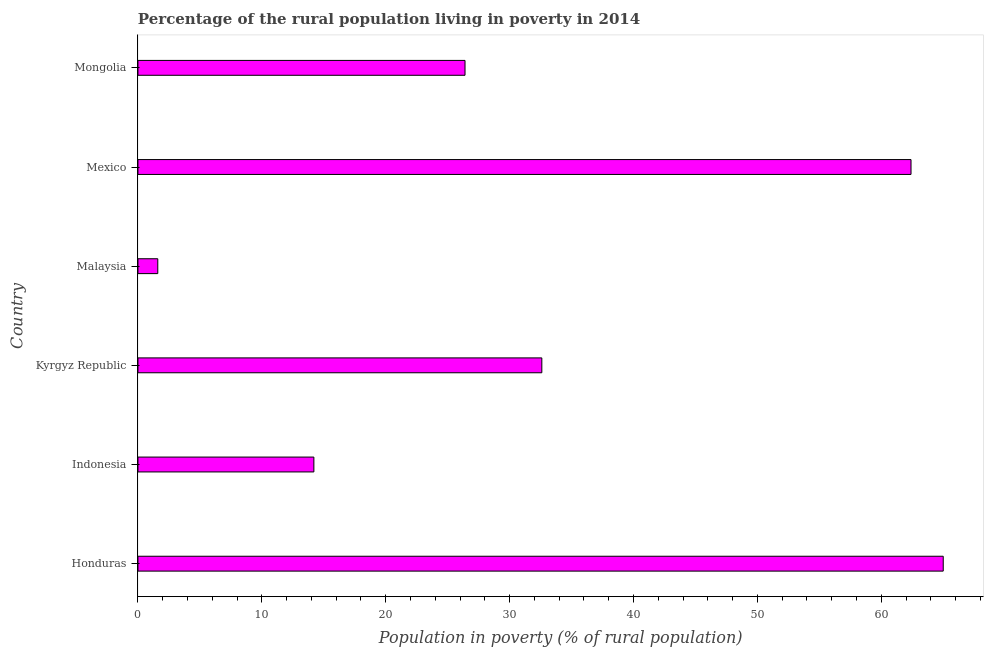Does the graph contain grids?
Ensure brevity in your answer.  No. What is the title of the graph?
Your response must be concise. Percentage of the rural population living in poverty in 2014. What is the label or title of the X-axis?
Ensure brevity in your answer.  Population in poverty (% of rural population). What is the percentage of rural population living below poverty line in Kyrgyz Republic?
Offer a very short reply. 32.6. Across all countries, what is the maximum percentage of rural population living below poverty line?
Make the answer very short. 65. Across all countries, what is the minimum percentage of rural population living below poverty line?
Your answer should be very brief. 1.6. In which country was the percentage of rural population living below poverty line maximum?
Offer a terse response. Honduras. In which country was the percentage of rural population living below poverty line minimum?
Provide a short and direct response. Malaysia. What is the sum of the percentage of rural population living below poverty line?
Offer a terse response. 202.2. What is the difference between the percentage of rural population living below poverty line in Kyrgyz Republic and Mexico?
Make the answer very short. -29.8. What is the average percentage of rural population living below poverty line per country?
Provide a succinct answer. 33.7. What is the median percentage of rural population living below poverty line?
Give a very brief answer. 29.5. In how many countries, is the percentage of rural population living below poverty line greater than 46 %?
Your response must be concise. 2. What is the ratio of the percentage of rural population living below poverty line in Honduras to that in Kyrgyz Republic?
Your response must be concise. 1.99. Is the percentage of rural population living below poverty line in Malaysia less than that in Mexico?
Offer a terse response. Yes. Is the sum of the percentage of rural population living below poverty line in Indonesia and Mexico greater than the maximum percentage of rural population living below poverty line across all countries?
Provide a short and direct response. Yes. What is the difference between the highest and the lowest percentage of rural population living below poverty line?
Provide a short and direct response. 63.4. What is the Population in poverty (% of rural population) of Kyrgyz Republic?
Your answer should be compact. 32.6. What is the Population in poverty (% of rural population) in Mexico?
Your response must be concise. 62.4. What is the Population in poverty (% of rural population) of Mongolia?
Keep it short and to the point. 26.4. What is the difference between the Population in poverty (% of rural population) in Honduras and Indonesia?
Provide a succinct answer. 50.8. What is the difference between the Population in poverty (% of rural population) in Honduras and Kyrgyz Republic?
Ensure brevity in your answer.  32.4. What is the difference between the Population in poverty (% of rural population) in Honduras and Malaysia?
Offer a very short reply. 63.4. What is the difference between the Population in poverty (% of rural population) in Honduras and Mongolia?
Your answer should be compact. 38.6. What is the difference between the Population in poverty (% of rural population) in Indonesia and Kyrgyz Republic?
Offer a terse response. -18.4. What is the difference between the Population in poverty (% of rural population) in Indonesia and Malaysia?
Give a very brief answer. 12.6. What is the difference between the Population in poverty (% of rural population) in Indonesia and Mexico?
Your answer should be compact. -48.2. What is the difference between the Population in poverty (% of rural population) in Indonesia and Mongolia?
Provide a succinct answer. -12.2. What is the difference between the Population in poverty (% of rural population) in Kyrgyz Republic and Mexico?
Make the answer very short. -29.8. What is the difference between the Population in poverty (% of rural population) in Kyrgyz Republic and Mongolia?
Ensure brevity in your answer.  6.2. What is the difference between the Population in poverty (% of rural population) in Malaysia and Mexico?
Your answer should be very brief. -60.8. What is the difference between the Population in poverty (% of rural population) in Malaysia and Mongolia?
Your answer should be compact. -24.8. What is the ratio of the Population in poverty (% of rural population) in Honduras to that in Indonesia?
Provide a short and direct response. 4.58. What is the ratio of the Population in poverty (% of rural population) in Honduras to that in Kyrgyz Republic?
Give a very brief answer. 1.99. What is the ratio of the Population in poverty (% of rural population) in Honduras to that in Malaysia?
Your answer should be very brief. 40.62. What is the ratio of the Population in poverty (% of rural population) in Honduras to that in Mexico?
Your answer should be very brief. 1.04. What is the ratio of the Population in poverty (% of rural population) in Honduras to that in Mongolia?
Your answer should be compact. 2.46. What is the ratio of the Population in poverty (% of rural population) in Indonesia to that in Kyrgyz Republic?
Keep it short and to the point. 0.44. What is the ratio of the Population in poverty (% of rural population) in Indonesia to that in Malaysia?
Your answer should be compact. 8.88. What is the ratio of the Population in poverty (% of rural population) in Indonesia to that in Mexico?
Give a very brief answer. 0.23. What is the ratio of the Population in poverty (% of rural population) in Indonesia to that in Mongolia?
Your answer should be compact. 0.54. What is the ratio of the Population in poverty (% of rural population) in Kyrgyz Republic to that in Malaysia?
Keep it short and to the point. 20.38. What is the ratio of the Population in poverty (% of rural population) in Kyrgyz Republic to that in Mexico?
Offer a terse response. 0.52. What is the ratio of the Population in poverty (% of rural population) in Kyrgyz Republic to that in Mongolia?
Make the answer very short. 1.24. What is the ratio of the Population in poverty (% of rural population) in Malaysia to that in Mexico?
Give a very brief answer. 0.03. What is the ratio of the Population in poverty (% of rural population) in Malaysia to that in Mongolia?
Ensure brevity in your answer.  0.06. What is the ratio of the Population in poverty (% of rural population) in Mexico to that in Mongolia?
Keep it short and to the point. 2.36. 